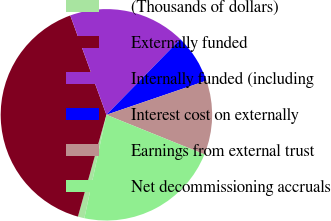Convert chart to OTSL. <chart><loc_0><loc_0><loc_500><loc_500><pie_chart><fcel>(Thousands of dollars)<fcel>Externally funded<fcel>Internally funded (including<fcel>Interest cost on externally<fcel>Earnings from external trust<fcel>Net decommissioning accruals<nl><fcel>1.0%<fcel>40.1%<fcel>17.87%<fcel>7.44%<fcel>11.35%<fcel>22.23%<nl></chart> 